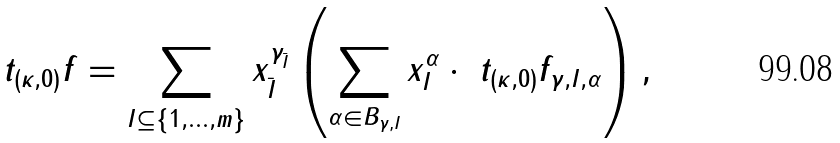Convert formula to latex. <formula><loc_0><loc_0><loc_500><loc_500>\ t _ { ( \kappa , 0 ) } f = \sum _ { I \subseteq \{ 1 , \dots , m \} } x _ { \bar { I } } ^ { \gamma _ { \bar { I } } } \left ( \sum _ { \alpha \in B _ { \gamma , I } } x _ { I } ^ { \alpha } \cdot \ t _ { ( \kappa , 0 ) } f _ { \gamma , I , \alpha } \right ) ,</formula> 